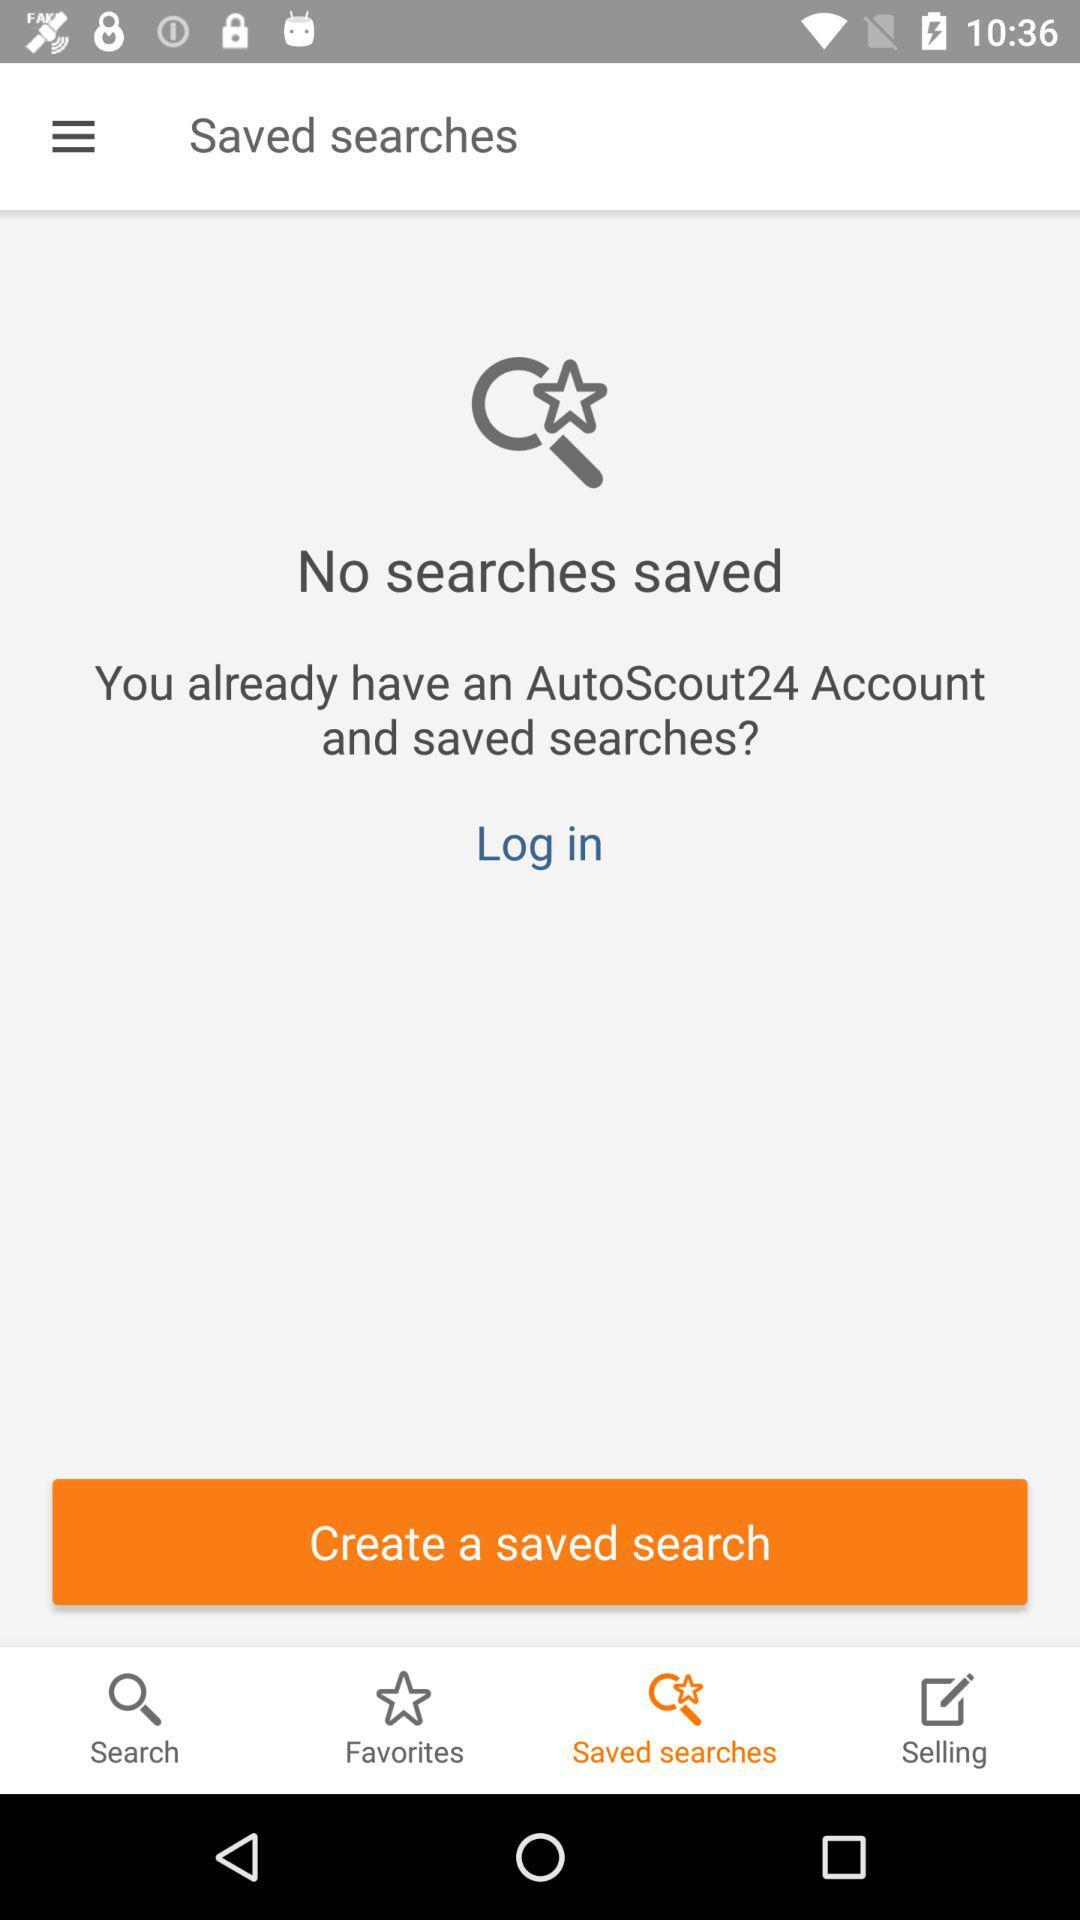What is the name of the application? The name of the application is "AutoScout24". 